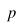<formula> <loc_0><loc_0><loc_500><loc_500>p</formula> 